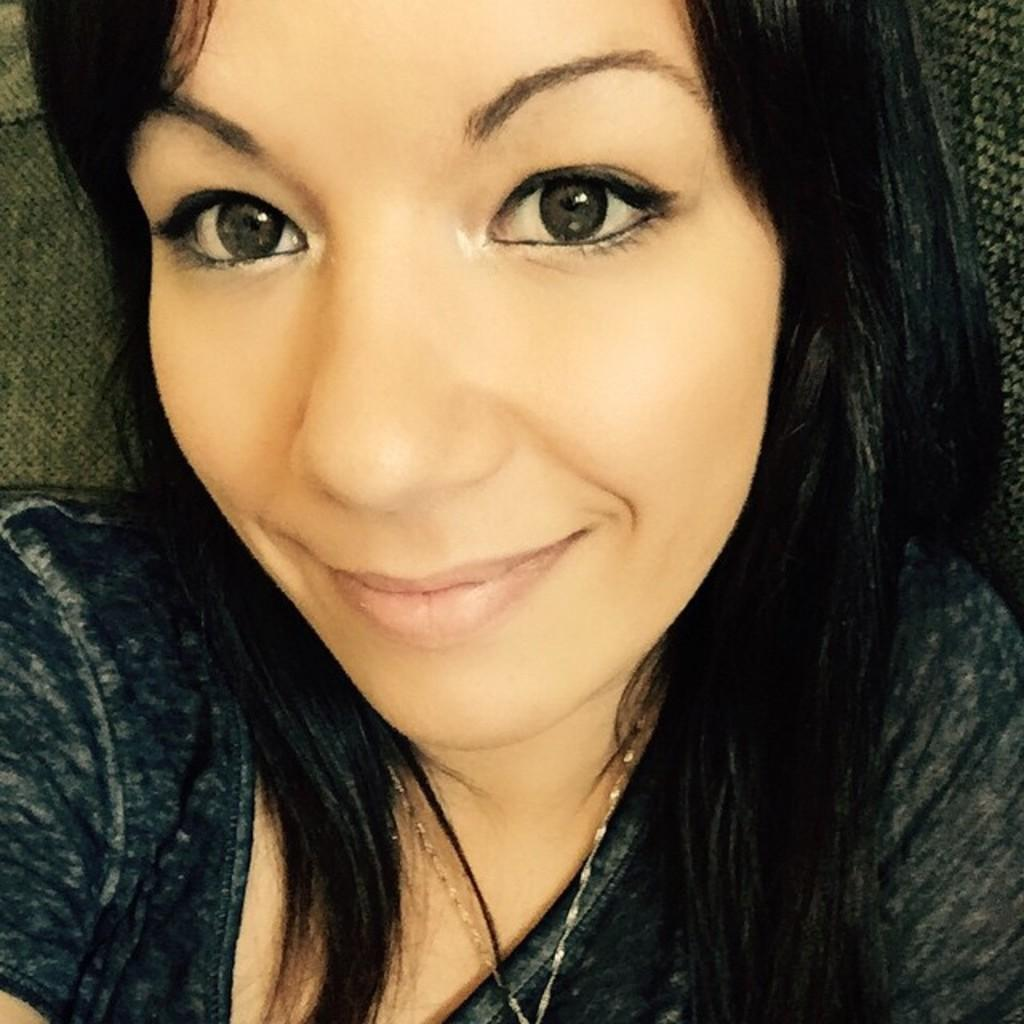Who is the main subject in the image? There is a woman in the image. Where is the woman located in the image? The woman is in the middle of the image. What type of pet is sitting next to the woman in the image? There is no pet present in the image; only the woman is visible. 